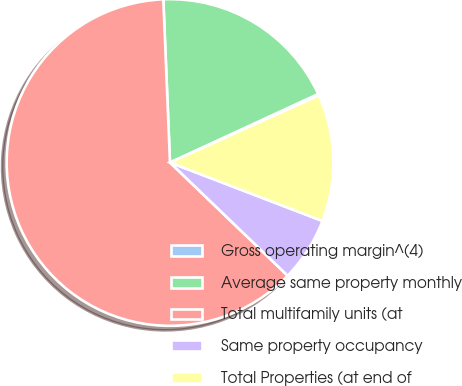Convert chart. <chart><loc_0><loc_0><loc_500><loc_500><pie_chart><fcel>Gross operating margin^(4)<fcel>Average same property monthly<fcel>Total multifamily units (at<fcel>Same property occupancy<fcel>Total Properties (at end of<nl><fcel>0.16%<fcel>18.76%<fcel>62.16%<fcel>6.36%<fcel>12.56%<nl></chart> 